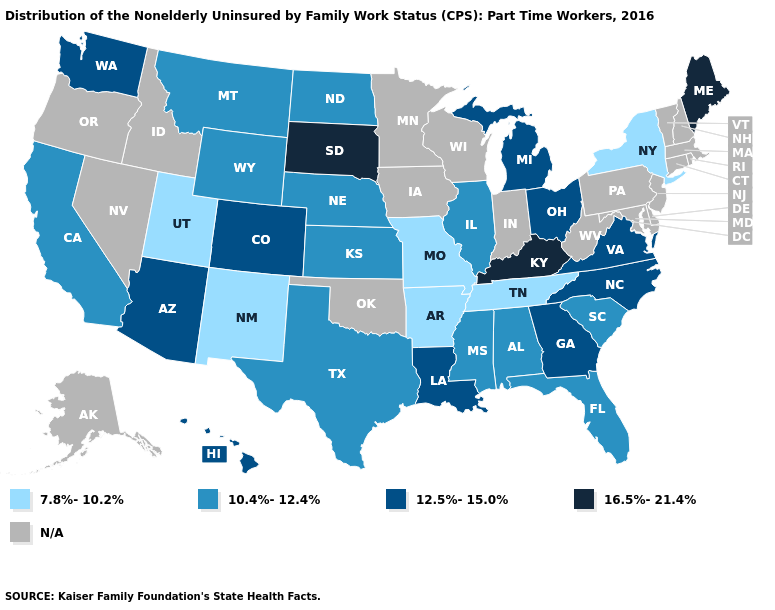Among the states that border Texas , does Louisiana have the lowest value?
Be succinct. No. What is the value of Alabama?
Write a very short answer. 10.4%-12.4%. What is the lowest value in states that border Florida?
Quick response, please. 10.4%-12.4%. Among the states that border Indiana , does Michigan have the lowest value?
Give a very brief answer. No. Name the states that have a value in the range N/A?
Short answer required. Alaska, Connecticut, Delaware, Idaho, Indiana, Iowa, Maryland, Massachusetts, Minnesota, Nevada, New Hampshire, New Jersey, Oklahoma, Oregon, Pennsylvania, Rhode Island, Vermont, West Virginia, Wisconsin. Does the first symbol in the legend represent the smallest category?
Short answer required. Yes. What is the value of Wisconsin?
Keep it brief. N/A. Name the states that have a value in the range 7.8%-10.2%?
Quick response, please. Arkansas, Missouri, New Mexico, New York, Tennessee, Utah. Name the states that have a value in the range N/A?
Be succinct. Alaska, Connecticut, Delaware, Idaho, Indiana, Iowa, Maryland, Massachusetts, Minnesota, Nevada, New Hampshire, New Jersey, Oklahoma, Oregon, Pennsylvania, Rhode Island, Vermont, West Virginia, Wisconsin. What is the value of Oregon?
Concise answer only. N/A. Which states have the lowest value in the South?
Keep it brief. Arkansas, Tennessee. Among the states that border Iowa , does South Dakota have the highest value?
Write a very short answer. Yes. Name the states that have a value in the range 10.4%-12.4%?
Keep it brief. Alabama, California, Florida, Illinois, Kansas, Mississippi, Montana, Nebraska, North Dakota, South Carolina, Texas, Wyoming. Which states have the lowest value in the USA?
Short answer required. Arkansas, Missouri, New Mexico, New York, Tennessee, Utah. 